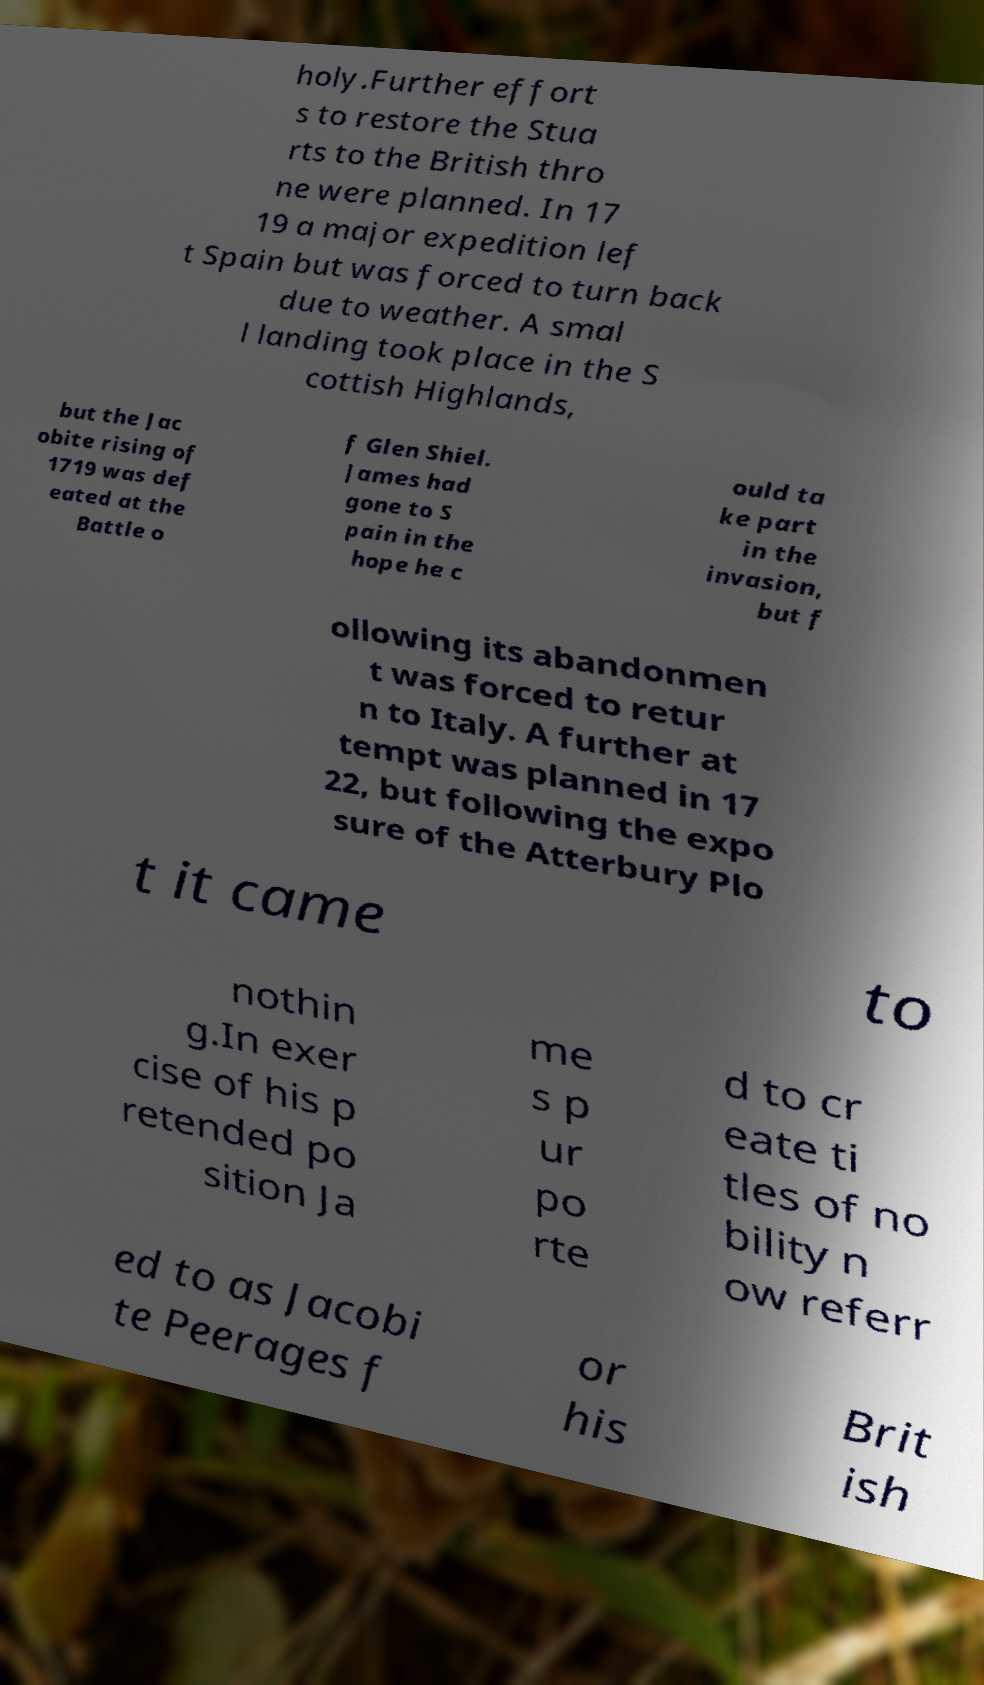Can you accurately transcribe the text from the provided image for me? holy.Further effort s to restore the Stua rts to the British thro ne were planned. In 17 19 a major expedition lef t Spain but was forced to turn back due to weather. A smal l landing took place in the S cottish Highlands, but the Jac obite rising of 1719 was def eated at the Battle o f Glen Shiel. James had gone to S pain in the hope he c ould ta ke part in the invasion, but f ollowing its abandonmen t was forced to retur n to Italy. A further at tempt was planned in 17 22, but following the expo sure of the Atterbury Plo t it came to nothin g.In exer cise of his p retended po sition Ja me s p ur po rte d to cr eate ti tles of no bility n ow referr ed to as Jacobi te Peerages f or his Brit ish 